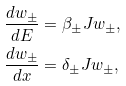<formula> <loc_0><loc_0><loc_500><loc_500>& \frac { d w _ { \pm } } { d E } = \beta _ { \pm } J w _ { \pm } , \\ & \frac { d w _ { \pm } } { d x } = \delta _ { \pm } J w _ { \pm } ,</formula> 